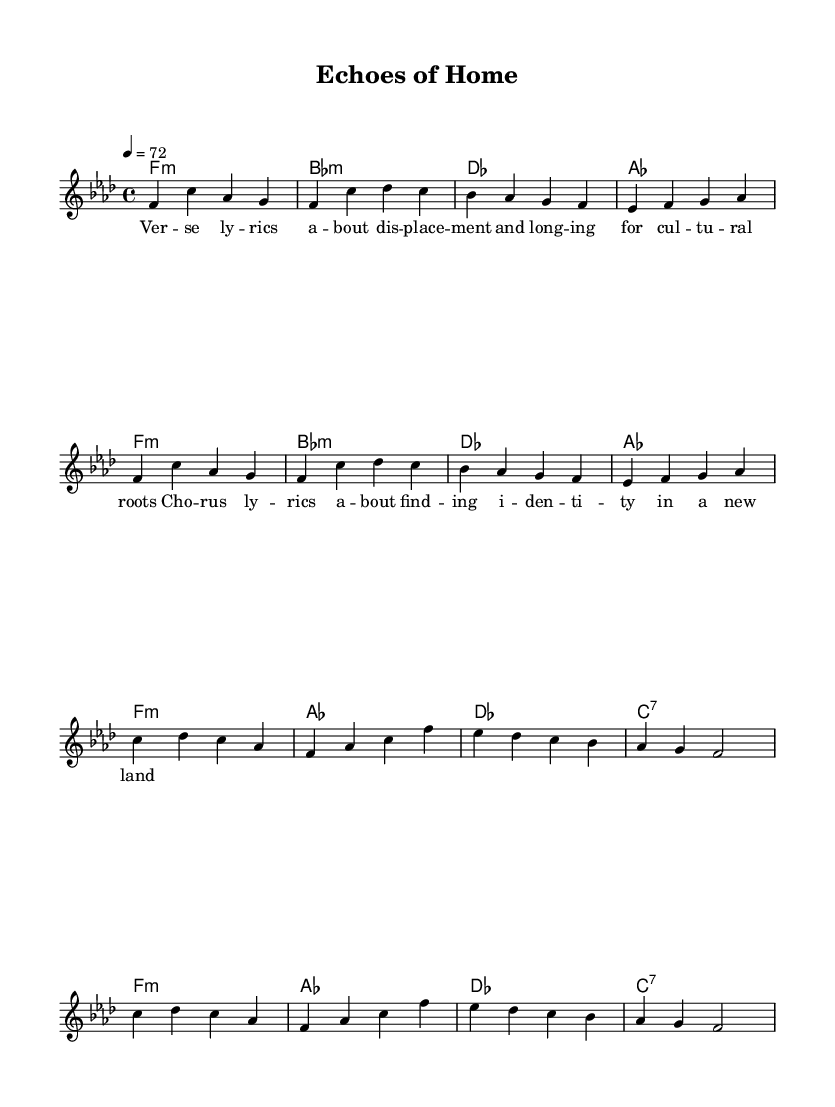What is the key signature of this music? The key signature is F minor, indicated by four flats on the staff. This is confirmed by the presence of the note F as the tonic and the absence of any sharps or additional accidentals.
Answer: F minor What is the time signature of this music? The time signature is 4/4, as shown at the beginning of the staff. This means there are four beats in each measure, and the quarter note receives one beat.
Answer: 4/4 What is the tempo marking for this piece? The tempo marking indicates a speed of 72 beats per minute, specified in the instructions at the beginning of the score.
Answer: 72 How many measures are repeated in the melody? The melody section repeats twice for a total of four measures as indicated by the repeat signs, which show that the same musical phrase is played again.
Answer: 2 What is the mood conveyed by the lyrics? The mood is one of longing and searching for identity, as indicated by the themes of displacement and cultural roots expressed through the lyrics in the verse and chorus.
Answer: Longing What type of harmony is used in the music? The harmony consists of minor chords and a seventh chord, which is typical in R&B music to create a rich emotive sound that supports themes of cultural identity and displacement.
Answer: Minor chords What are the main lyrical themes explored in the song? The main themes revolve around cultural identity and the experience of being displaced, reflecting R&B's connection to personal and collective experiences, typically related to the diaspora.
Answer: Cultural identity 